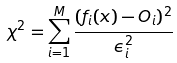Convert formula to latex. <formula><loc_0><loc_0><loc_500><loc_500>\chi ^ { 2 } = \sum _ { i = 1 } ^ { M } \frac { ( f _ { i } ( { x } ) - O _ { i } ) ^ { 2 } } { \epsilon _ { i } ^ { 2 } }</formula> 